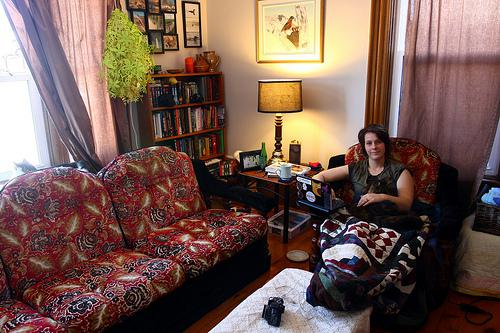Question: where was the picture taken?
Choices:
A. On the coast.
B. In the mountains.
C. A living room.
D. At the game.
Answer with the letter. Answer: C Question: what kind of light is shining through the windows?
Choices:
A. Street light.
B. Neon light.
C. Sunlight.
D. Fire glow.
Answer with the letter. Answer: C Question: what kind of electrical light is in the room?
Choices:
A. Cfc.
B. A lamp.
C. Led.
D. Flashlight.
Answer with the letter. Answer: B Question: what gender is the person?
Choices:
A. Male.
B. Impossible to identify.
C. Female.
D. Transgender.
Answer with the letter. Answer: C Question: what is the person sitting in?
Choices:
A. A chair.
B. A tub.
C. A hot tub.
D. Swimming pool.
Answer with the letter. Answer: A 